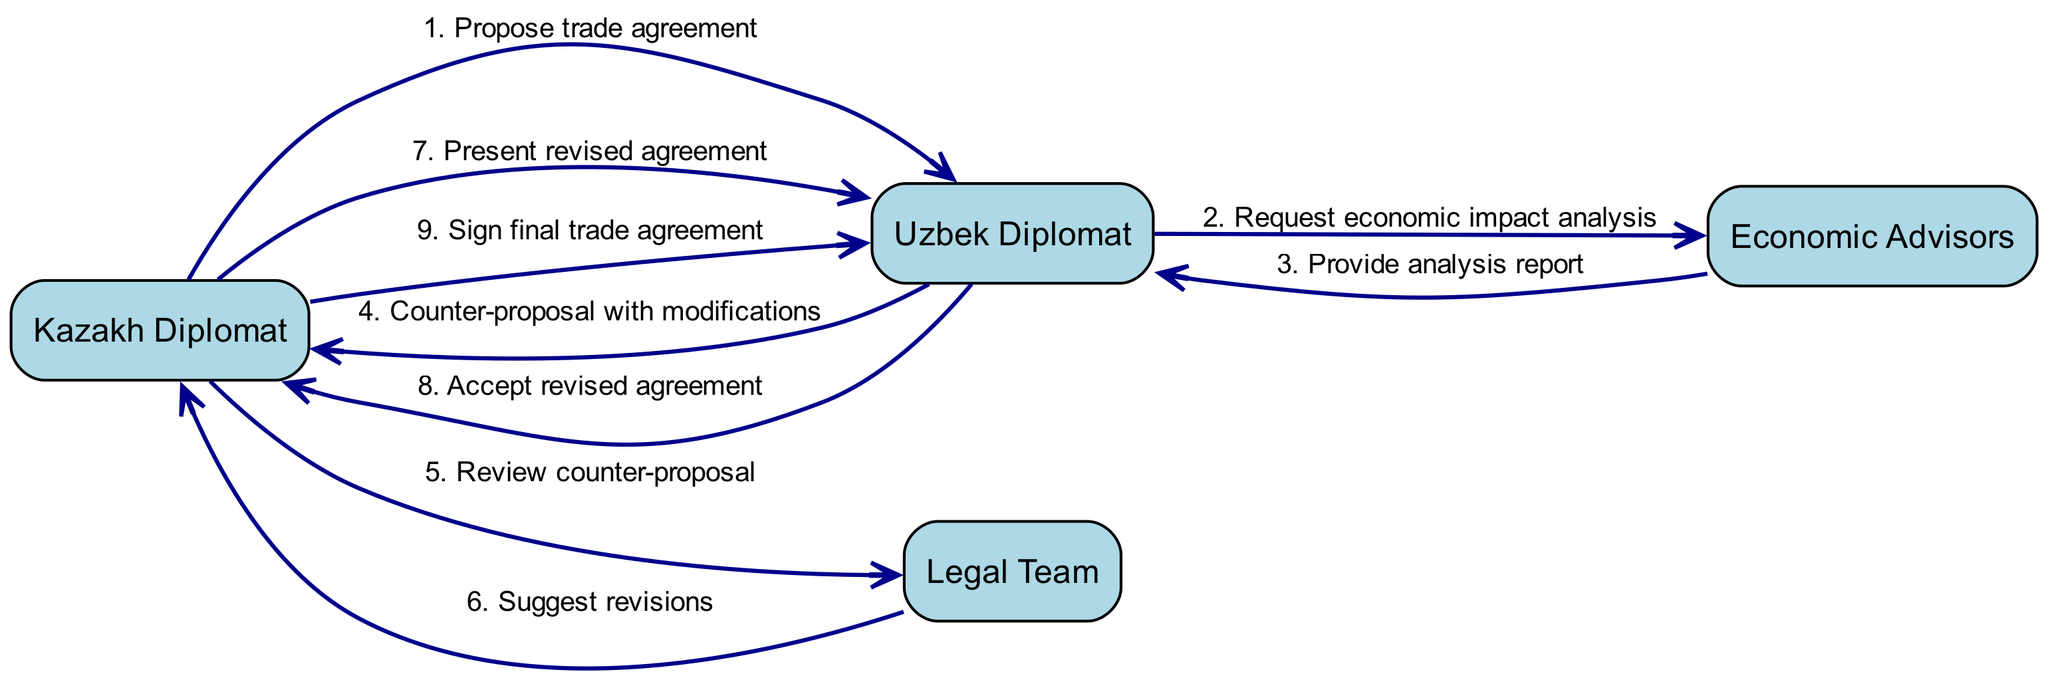What is the first message in the sequence? The first message in the sequence is sent from the Kazakh Diplomat to the Uzbek Diplomat, proposing a trade agreement.
Answer: Propose trade agreement Who is involved in reviewing the counter-proposal? The Kazakh Diplomat sends the counter-proposal to the Legal Team for review, meaning the Legal Team is involved in this process.
Answer: Legal Team How many messages are there in total? By counting all the individual messages exchanged in the sequence, there are nine messages in total.
Answer: 9 What message does the Uzbek Diplomat send after receiving the economic impact analysis? After receiving the economic impact analysis, the Uzbek Diplomat sends a counter-proposal with modifications.
Answer: Counter-proposal with modifications Which actor presents the revised agreement? The revised agreement is presented by the Kazakh Diplomat to the Uzbek Diplomat after reviewing the counter-proposal.
Answer: Kazakh Diplomat What is the final action taken in the sequence? The final action taken in the sequence is the signing of the final trade agreement by the Kazakh Diplomat with the Uzbek Diplomat.
Answer: Sign final trade agreement What kind of report do the Economic Advisors provide? The Economic Advisors provide an analysis report in response to the Uzbek Diplomat's request for an economic impact analysis.
Answer: Analysis report Which two actors interact before the final agreement is signed? Before the final agreement is signed, the Kazakh Diplomat interacts with the Uzbek Diplomat, discussing and accepting the revised agreement.
Answer: Kazakh Diplomat and Uzbek Diplomat What was the purpose of the communication between the Kazakh Diplomat and the Legal Team? The communication's purpose was for the Kazakh Diplomat to request a review of the counter-proposal from the Legal Team.
Answer: Review counter-proposal 